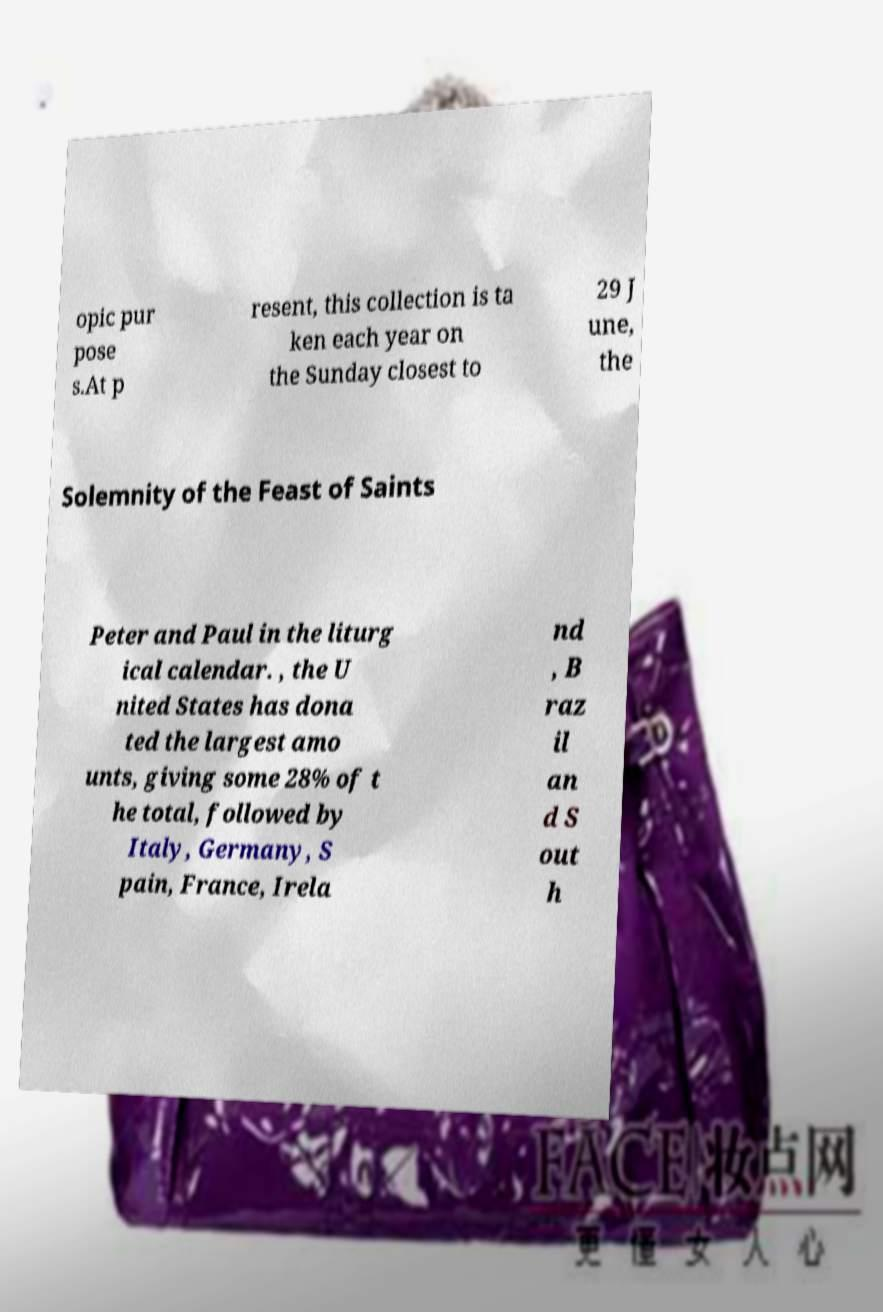Could you assist in decoding the text presented in this image and type it out clearly? opic pur pose s.At p resent, this collection is ta ken each year on the Sunday closest to 29 J une, the Solemnity of the Feast of Saints Peter and Paul in the liturg ical calendar. , the U nited States has dona ted the largest amo unts, giving some 28% of t he total, followed by Italy, Germany, S pain, France, Irela nd , B raz il an d S out h 